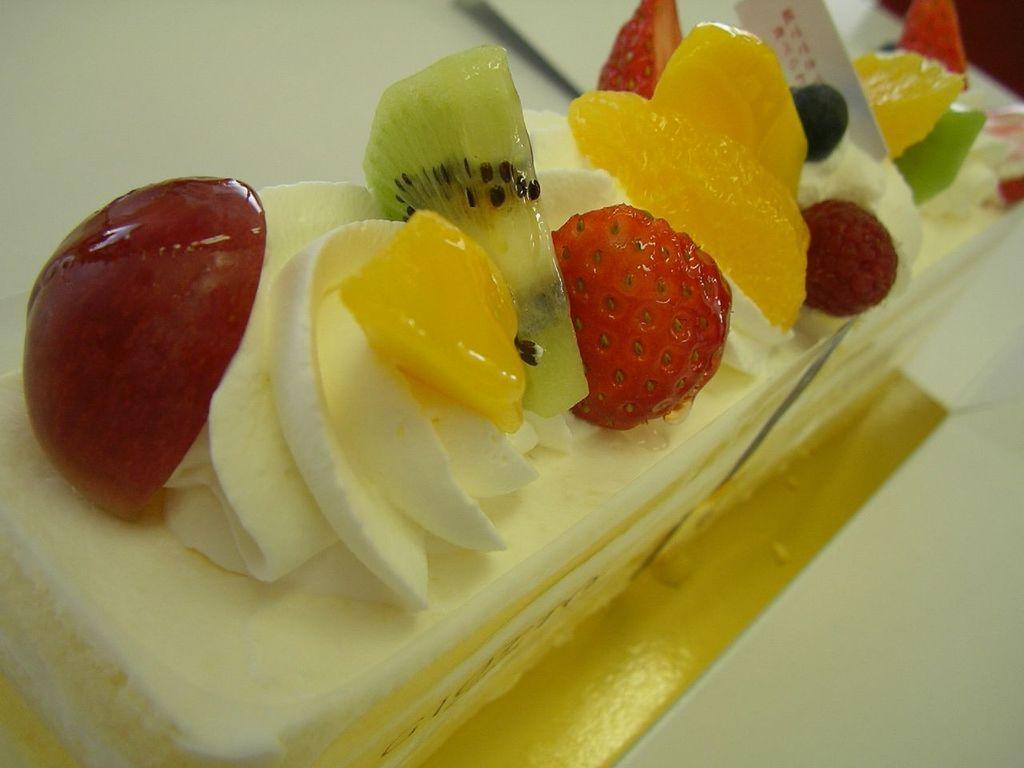Can you describe this image briefly? In this image there is a piece of cake on which there are fruits like strawberry,cherries,pineapple and a kiwi fruit on it. 